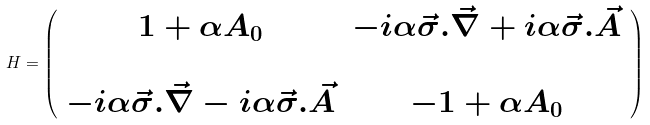<formula> <loc_0><loc_0><loc_500><loc_500>H = \left ( \begin{array} { c c } 1 + \alpha A _ { 0 } & - i \alpha \vec { \sigma } . \vec { \nabla } + i \alpha \vec { \sigma } . \vec { A } \\ \\ - i \alpha \vec { \sigma } . \vec { \nabla } - i \alpha \vec { \sigma } . \vec { A } & - 1 + \alpha A _ { 0 } \end{array} \right )</formula> 